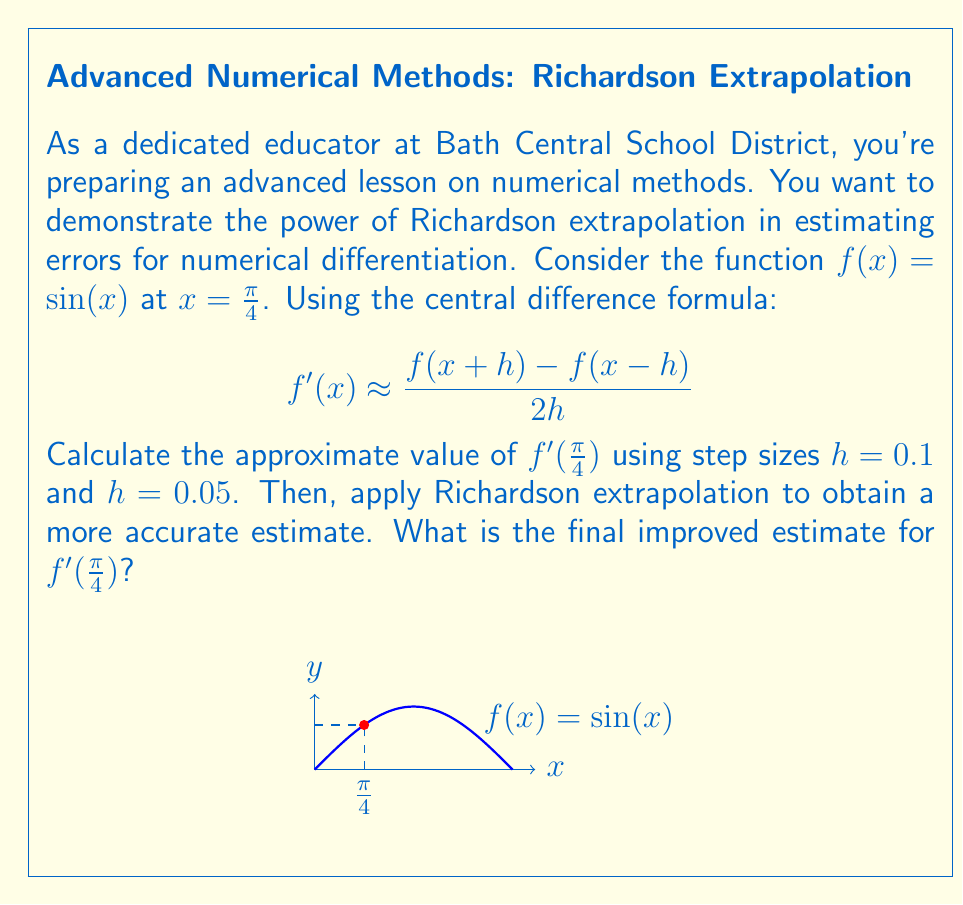Solve this math problem. Let's approach this step-by-step:

1) First, we need to calculate $f'(\frac{\pi}{4})$ using $h = 0.1$:
   $$f'(\frac{\pi}{4}) \approx \frac{f(\frac{\pi}{4}+0.1) - f(\frac{\pi}{4}-0.1)}{2(0.1)}$$
   $$= \frac{\sin(\frac{\pi}{4}+0.1) - \sin(\frac{\pi}{4}-0.1)}{0.2}$$
   $$= \frac{0.7818 - 0.6344}{0.2} = 0.7370$$

2) Now, let's calculate using $h = 0.05$:
   $$f'(\frac{\pi}{4}) \approx \frac{f(\frac{\pi}{4}+0.05) - f(\frac{\pi}{4}-0.05)}{2(0.05)}$$
   $$= \frac{\sin(\frac{\pi}{4}+0.05) - \sin(\frac{\pi}{4}-0.05)}{0.1}$$
   $$= \frac{0.7141 - 0.7000}{0.1} = 0.7071$$

3) The true value of $f'(\frac{\pi}{4}) = \cos(\frac{\pi}{4}) = \frac{\sqrt{2}}{2} \approx 0.7071068$.

4) Now, let's apply Richardson extrapolation. The formula is:
   $$f'(x) \approx \frac{4D_h - D_{2h}}{3}$$
   where $D_h$ is the approximation with step size $h$.

5) Plugging in our values:
   $$f'(\frac{\pi}{4}) \approx \frac{4(0.7071) - 0.7370}{3}$$
   $$= \frac{2.8284 - 0.7370}{3} = 0.7071333$$

This final value is our improved estimate using Richardson extrapolation.
Answer: $0.7071333$ 